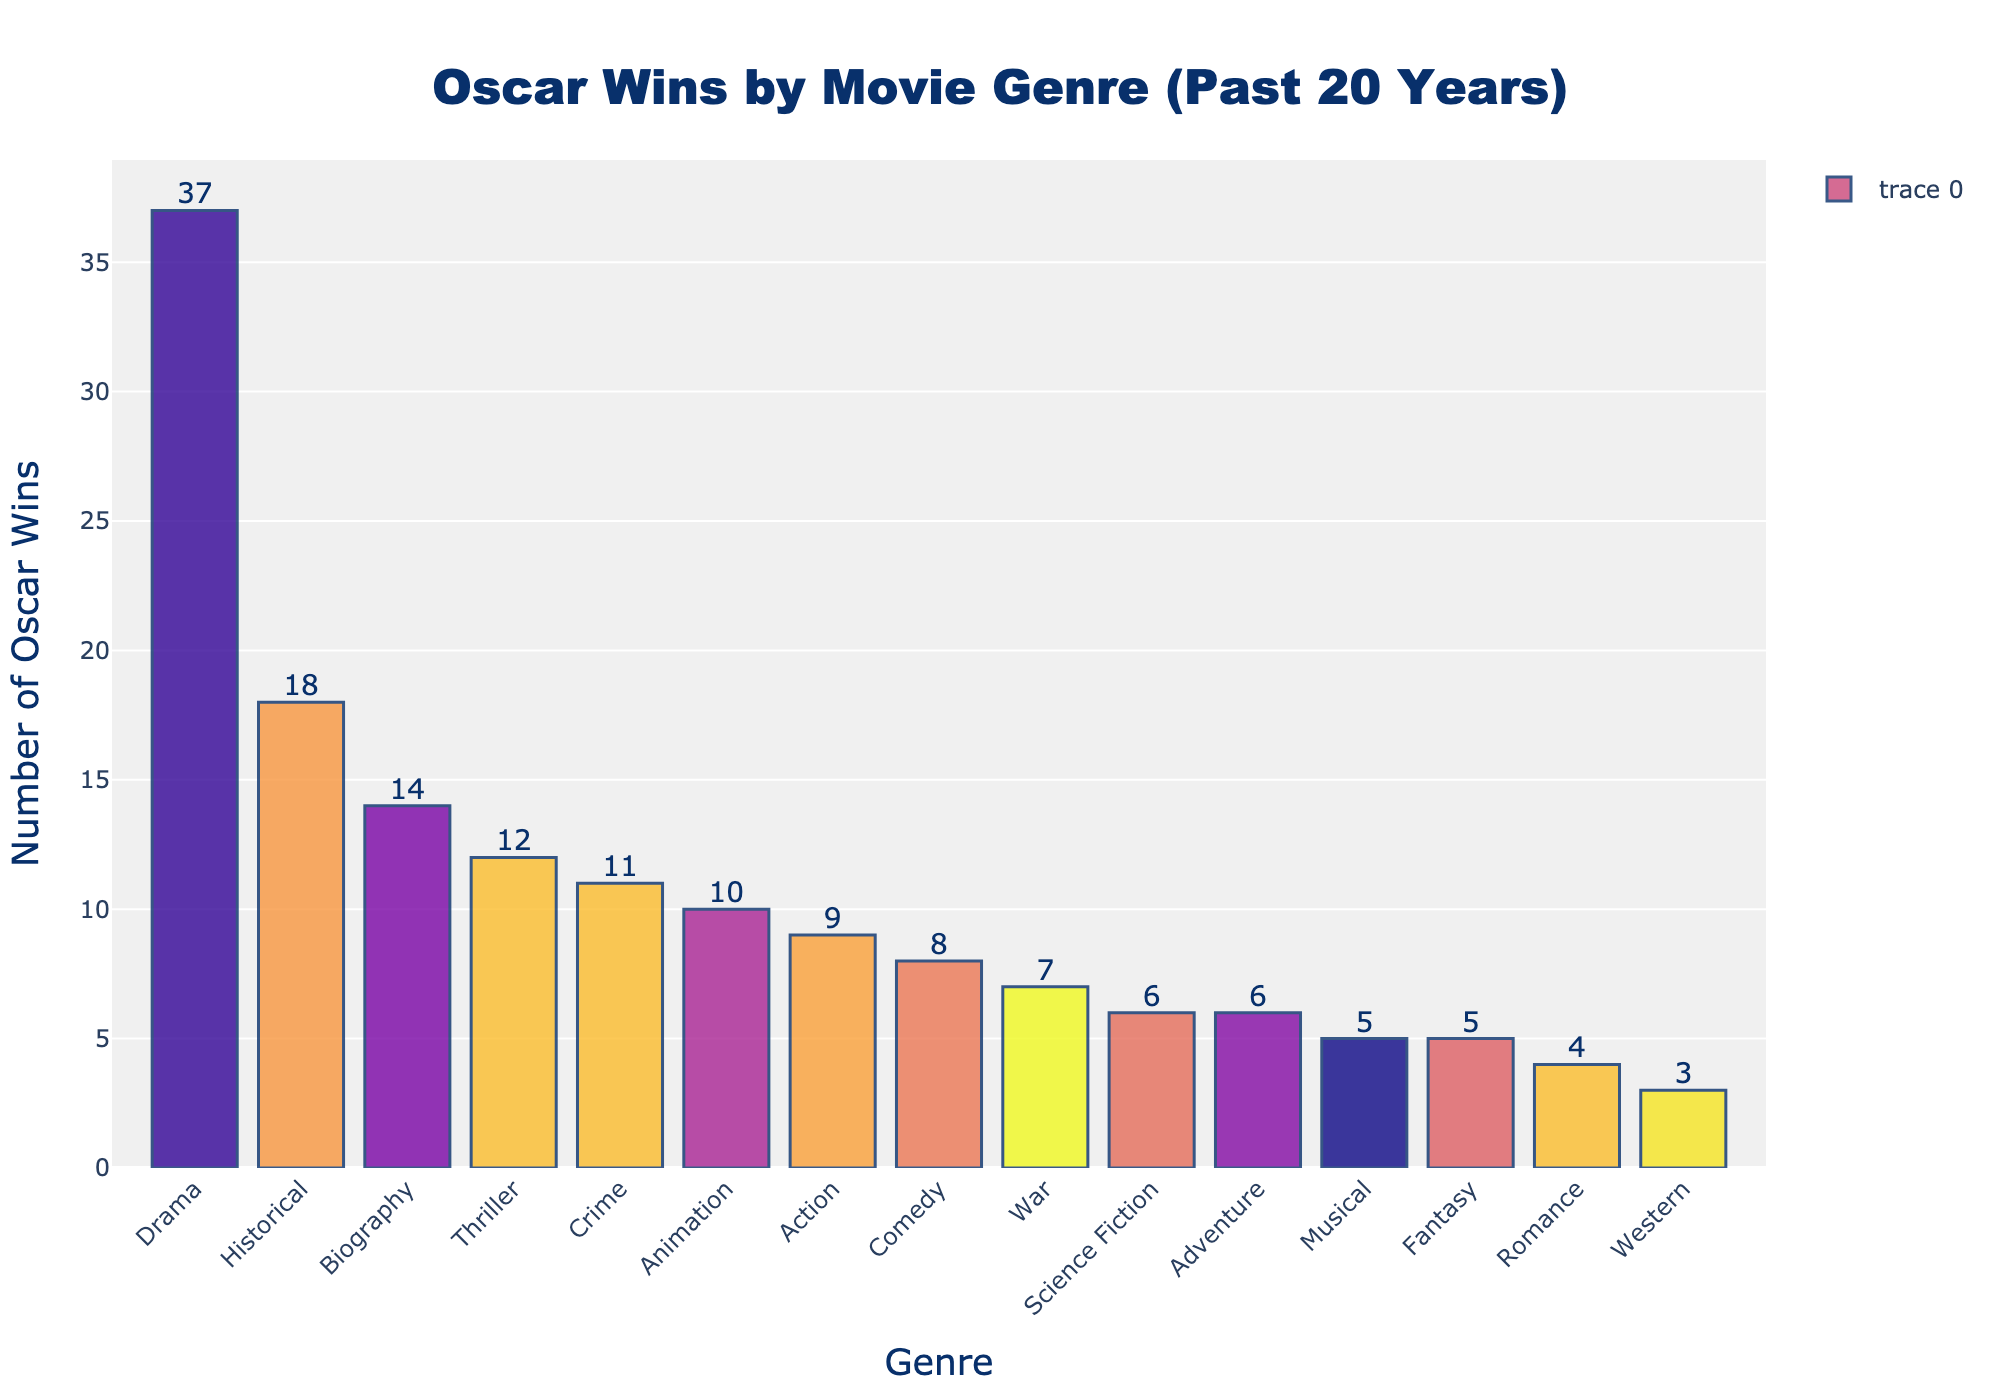How many more Oscar wins does Drama have compared to Comedy? First, find the number of Oscar wins for Drama (37) and Comedy (8). Then subtract the number of wins for Comedy from the number of wins for Drama: 37 - 8 = 29.
Answer: 29 Which genre has the third highest number of Oscar wins? Sort the genres by the number of Oscar wins in descending order. The genres with the highest wins are Drama (37), Historical (18), and Biography (14). Therefore, Biography has the third highest number of Oscar wins.
Answer: Biography What is the total number of Oscar wins for genres with more than 10 wins? First, identify the genres with more than 10 Oscar wins: Drama (37), Thriller (12), Historical (18), Biography (14), and Animation (10). Then add up the wins: 37 + 12 + 18 + 14 + 10 = 91.
Answer: 91 Which genre has the lowest number of Oscar wins? Look at the bars and identify the one with the smallest height. Western is the genre with the lowest number of Oscar wins, which is 3.
Answer: Western What is the average number of Oscar wins across all genres? First, add all the Oscar wins together: 37 + 8 + 12 + 6 + 18 + 5 + 9 + 4 + 14 + 7 + 5 + 11 + 6 + 10 + 3 = 155. Then divide by the number of genres: 155 / 15 = 10.33.
Answer: 10.33 How much taller is the bar for Drama compared to the bar for Science Fiction? Find the number of Oscar wins for Drama (37) and Science Fiction (6). Then subtract the number of wins for Science Fiction from the number of wins for Drama: 37 - 6 = 31.
Answer: 31 Which two genres have identical numbers of Oscar wins? Look for bars of equal height. The two genres with the same number of Oscar wins are Science Fiction and Adventure, both with 6 wins.
Answer: Science Fiction and Adventure How many genres have fewer than 10 Oscar wins each? Identify the genres with fewer than 10 Oscar wins: Comedy (8), Science Fiction (6), Musical (5), Romance (4), War (7), Fantasy (5), Adventure (6), and Western (3). Count them: 8 genres.
Answer: 8 What percentage of the total Oscar wins is represented by Thrillers? First, find the total number of Oscar wins (155). Then find the number of Oscar wins for Thrillers (12). Calculate the percentage: (12 / 155) * 100 ≈ 7.74%.
Answer: 7.74% Is there a genre with exactly 5 Oscar wins? Scan through the bars and find the one with a height corresponding to 5 wins. Both Musical and Fantasy have exactly 5 Oscar wins.
Answer: Musical and Fantasy 